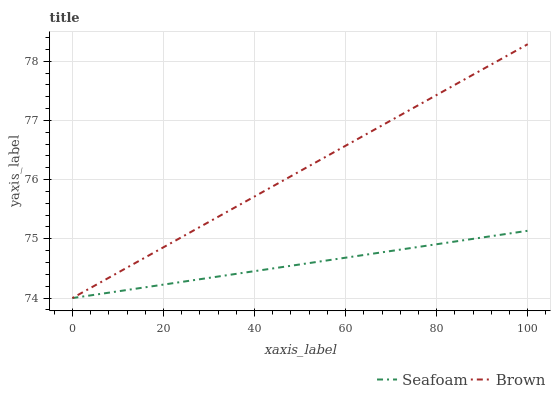Does Seafoam have the minimum area under the curve?
Answer yes or no. Yes. Does Brown have the maximum area under the curve?
Answer yes or no. Yes. Does Seafoam have the maximum area under the curve?
Answer yes or no. No. Is Seafoam the smoothest?
Answer yes or no. Yes. Is Brown the roughest?
Answer yes or no. Yes. Is Seafoam the roughest?
Answer yes or no. No. Does Seafoam have the highest value?
Answer yes or no. No. 